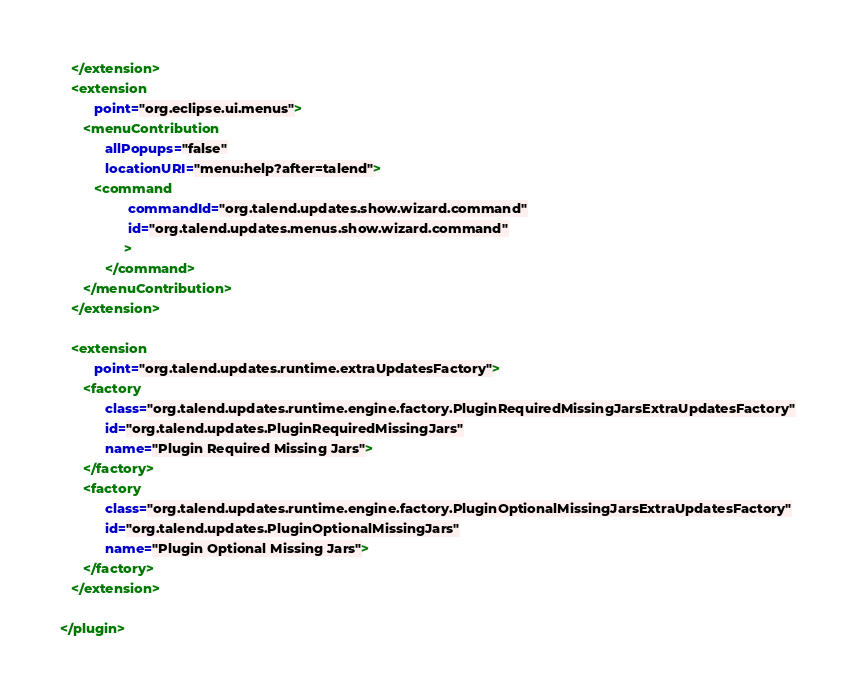Convert code to text. <code><loc_0><loc_0><loc_500><loc_500><_XML_>   </extension>
   <extension
         point="org.eclipse.ui.menus">
      <menuContribution
            allPopups="false"
            locationURI="menu:help?after=talend">
         <command
                  commandId="org.talend.updates.show.wizard.command"
                  id="org.talend.updates.menus.show.wizard.command"
                 >
            </command>
      </menuContribution>
   </extension>
   
   <extension
         point="org.talend.updates.runtime.extraUpdatesFactory">
      <factory
            class="org.talend.updates.runtime.engine.factory.PluginRequiredMissingJarsExtraUpdatesFactory"
            id="org.talend.updates.PluginRequiredMissingJars"
            name="Plugin Required Missing Jars">
      </factory>
      <factory
            class="org.talend.updates.runtime.engine.factory.PluginOptionalMissingJarsExtraUpdatesFactory"
            id="org.talend.updates.PluginOptionalMissingJars"
            name="Plugin Optional Missing Jars">
      </factory>
   </extension>

</plugin>
</code> 